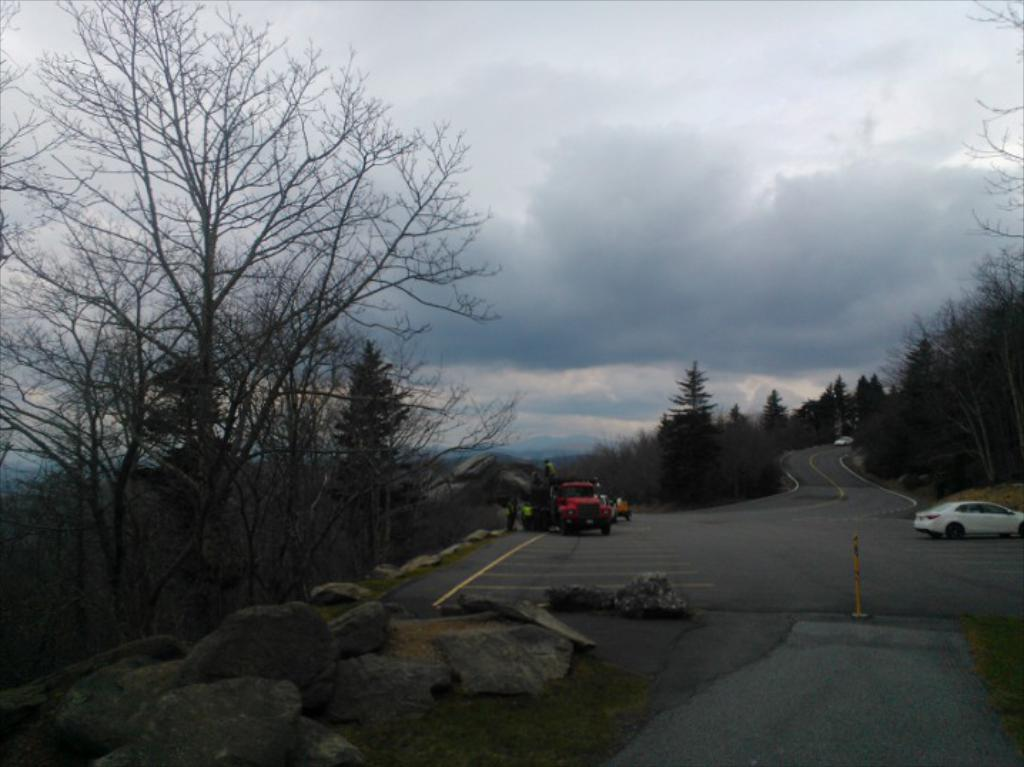What is the main feature of the image? There is a road in the image. What is happening on the road? There are cars on the road. Are there any obstacles on the road? Yes, there are stones on the road. What can be seen in the background of the image? There are trees and the sky visible in the background of the image. Where is the shelf located in the image? There is no shelf present in the image. What type of amusement can be seen in the image? There is no amusement depicted in the image; it features a road with cars and stones. 